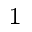Convert formula to latex. <formula><loc_0><loc_0><loc_500><loc_500>^ { 1 }</formula> 